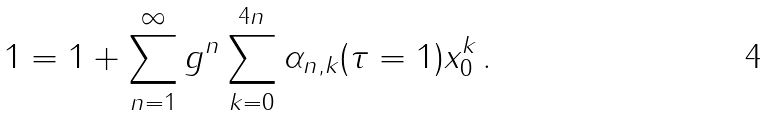<formula> <loc_0><loc_0><loc_500><loc_500>1 = 1 + \sum _ { n = 1 } ^ { \infty } g ^ { n } \sum _ { k = 0 } ^ { 4 n } \alpha _ { n , k } ( \tau = 1 ) x _ { 0 } ^ { k } \, .</formula> 